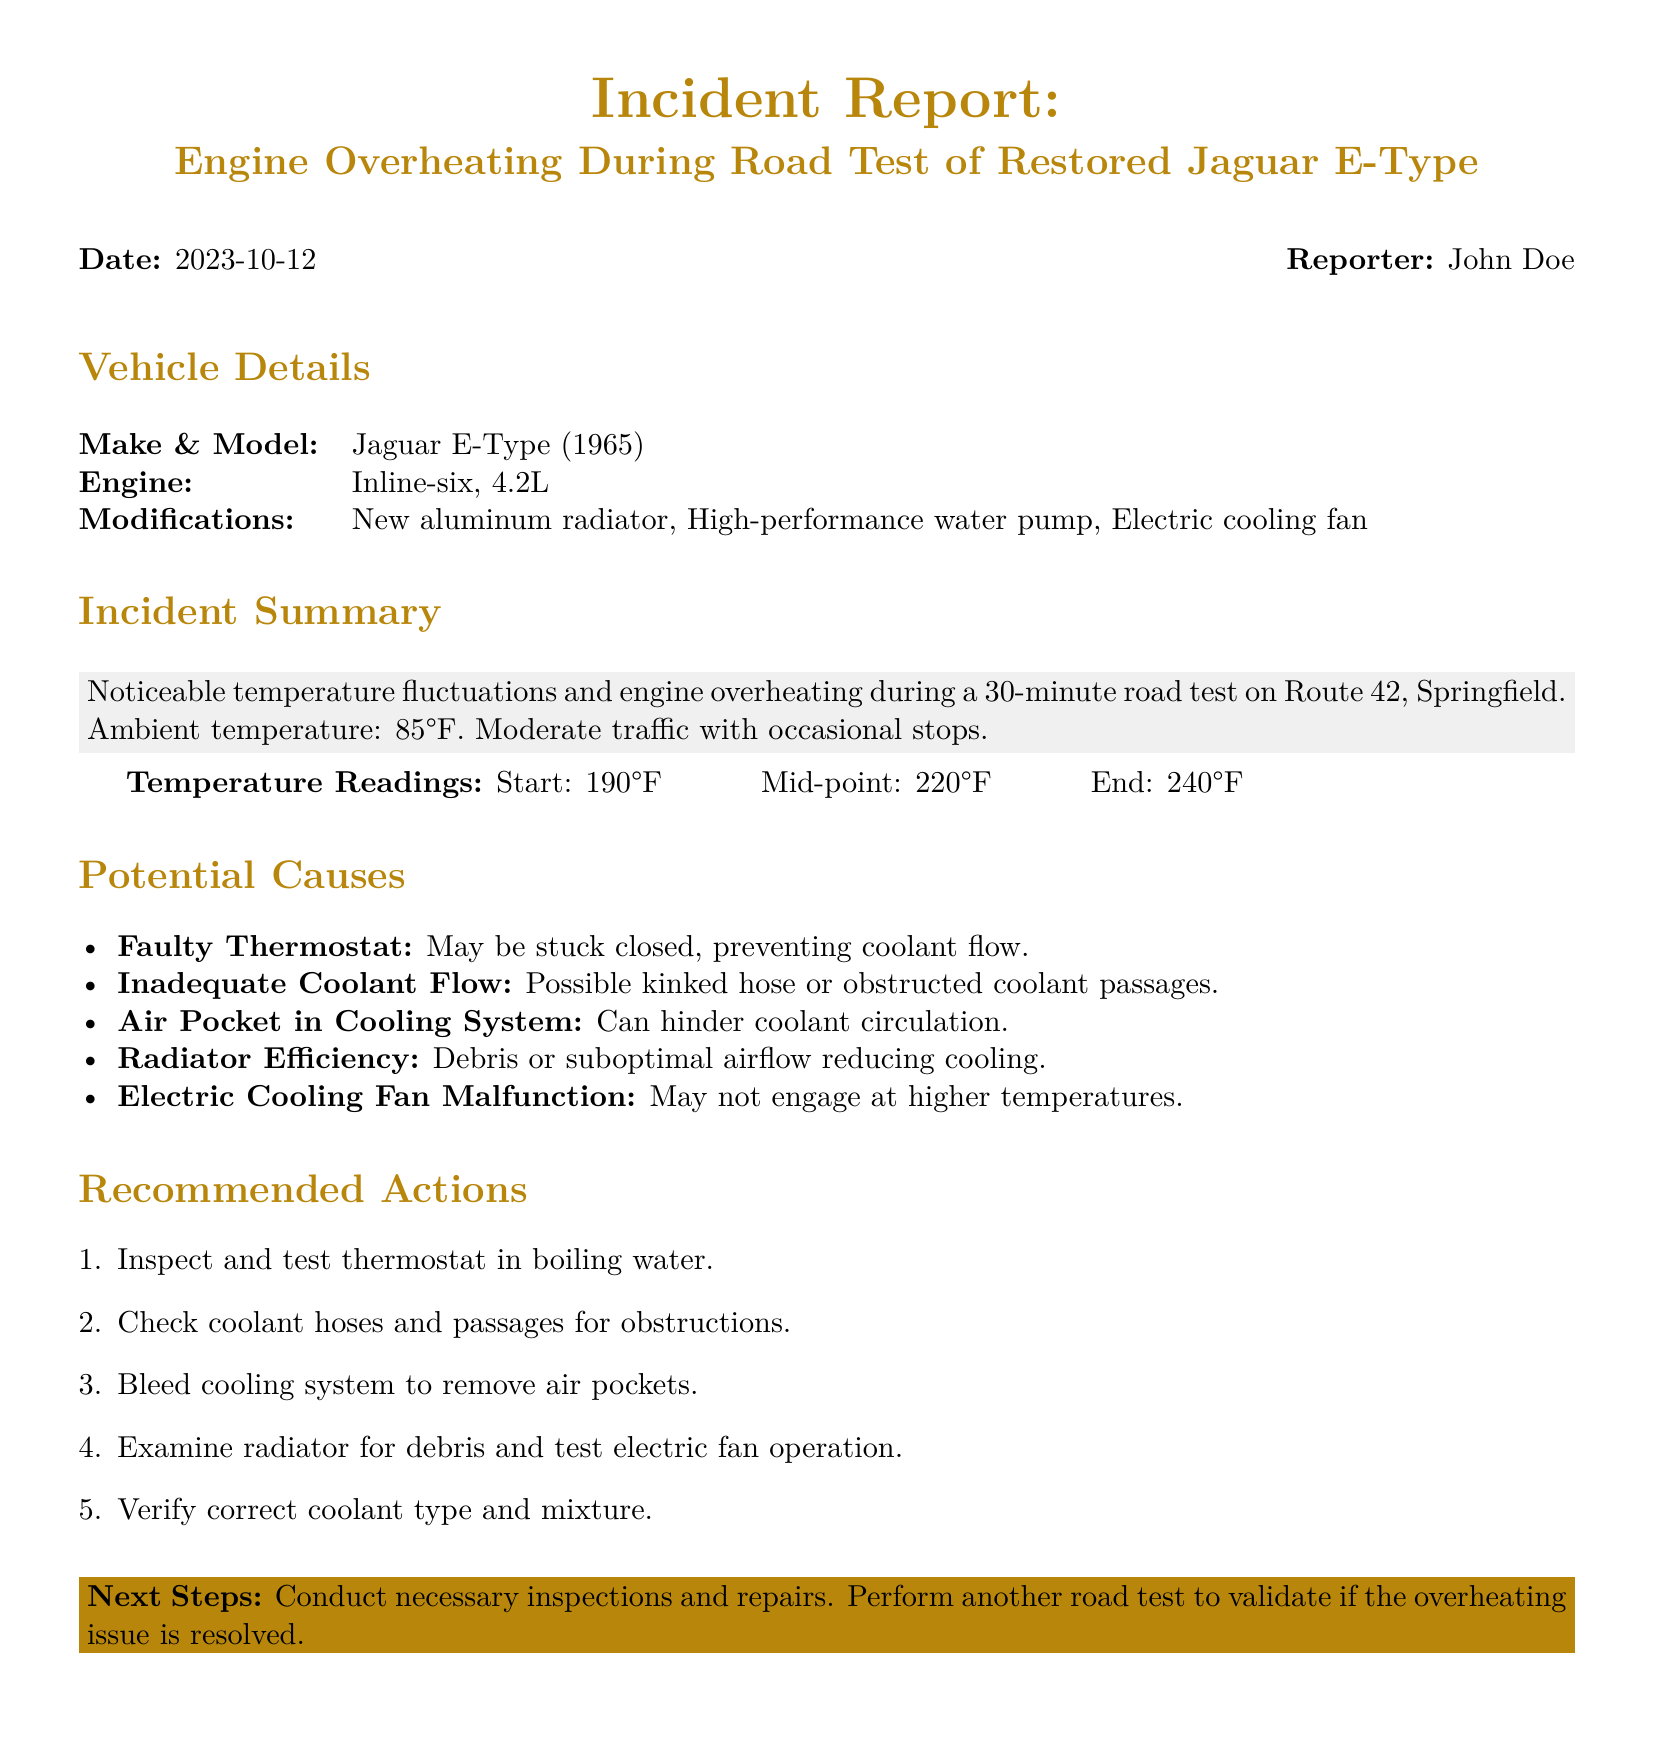What was the date of the incident? The date of the incident is stated as "2023-10-12" in the report.
Answer: 2023-10-12 What is the make and model of the vehicle? The make and model of the vehicle is specified in the "Vehicle Details" section of the report.
Answer: Jaguar E-Type (1965) What was the maximum temperature reading during the test? The maximum temperature is found in the "Temperature Readings" section, which lists the highest value observed during the road test.
Answer: 240°F What modification was made to the radiator? The report details modifications in the "Vehicle Details" section, mentioning the type of radiator used.
Answer: New aluminum radiator What is one potential cause of the overheating according to the report? The report lists several potential causes, providing insights into why the overheating may have occurred.
Answer: Faulty Thermostat How long did the road test last? The duration of the road test is mentioned in the "Incident Summary" section of the report.
Answer: 30 minutes What did the report recommend to inspect first? The recommended actions outline the first step to be performed, indicating the priority of inspections.
Answer: Inspect and test thermostat What was the ambient temperature during the incident? The ambient temperature is provided in the "Incident Summary" section of the report as part of the test conditions.
Answer: 85°F What type of engine does the vehicle have? The type of engine is specified in the "Vehicle Details" section of the report.
Answer: Inline-six, 4.2L 